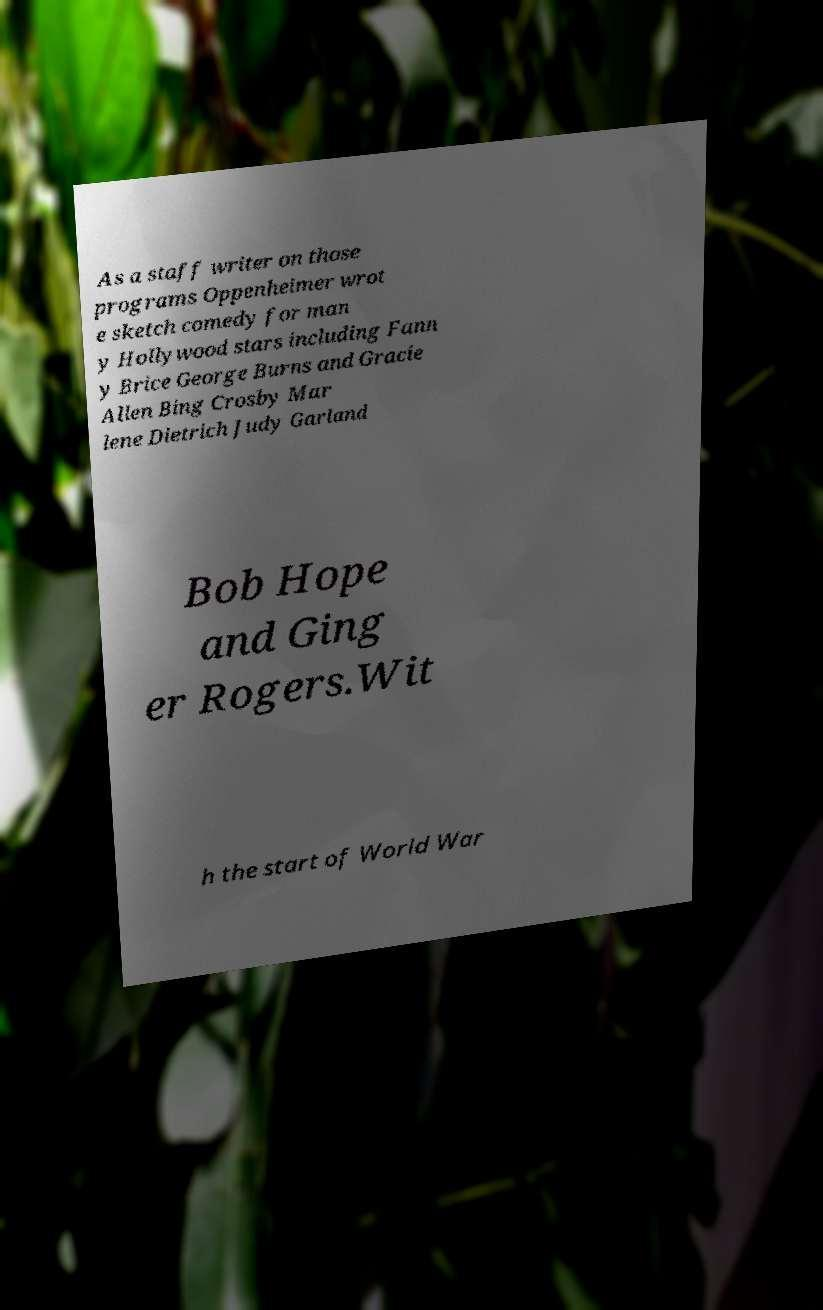Please read and relay the text visible in this image. What does it say? As a staff writer on those programs Oppenheimer wrot e sketch comedy for man y Hollywood stars including Fann y Brice George Burns and Gracie Allen Bing Crosby Mar lene Dietrich Judy Garland Bob Hope and Ging er Rogers.Wit h the start of World War 